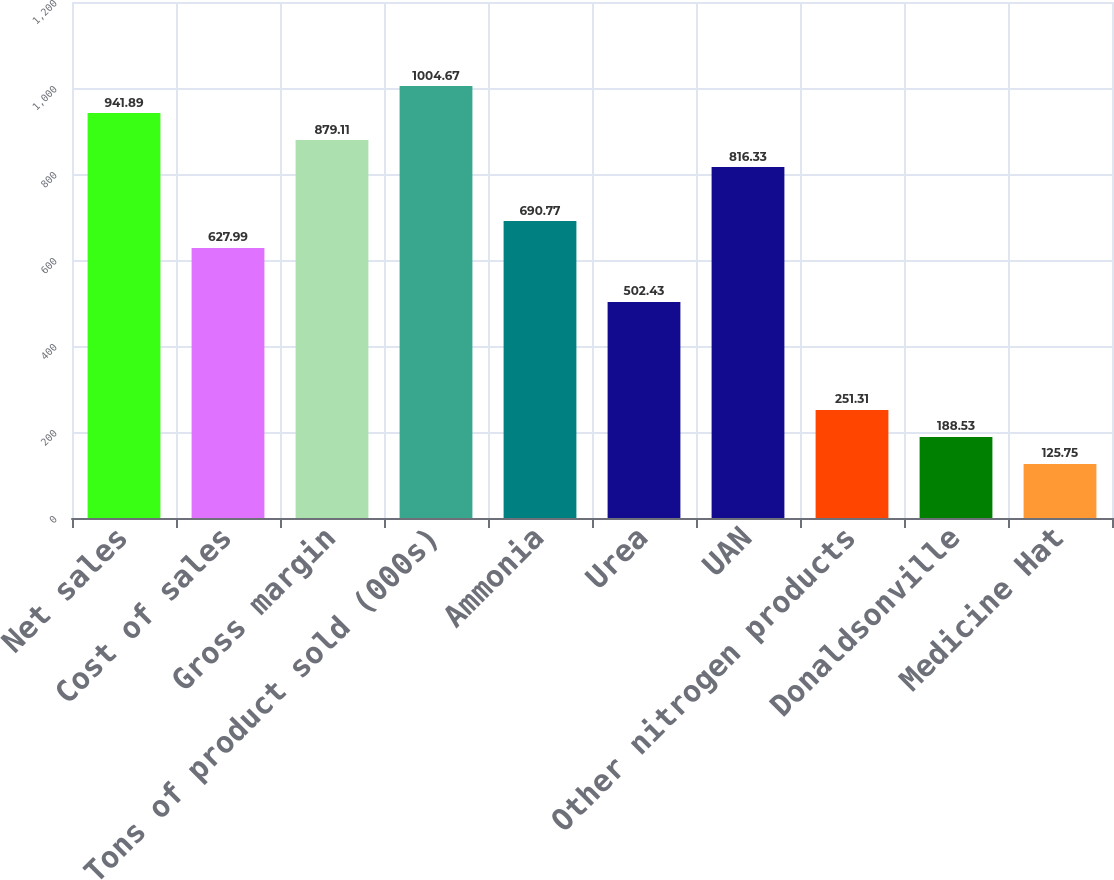Convert chart. <chart><loc_0><loc_0><loc_500><loc_500><bar_chart><fcel>Net sales<fcel>Cost of sales<fcel>Gross margin<fcel>Tons of product sold (000s)<fcel>Ammonia<fcel>Urea<fcel>UAN<fcel>Other nitrogen products<fcel>Donaldsonville<fcel>Medicine Hat<nl><fcel>941.89<fcel>627.99<fcel>879.11<fcel>1004.67<fcel>690.77<fcel>502.43<fcel>816.33<fcel>251.31<fcel>188.53<fcel>125.75<nl></chart> 